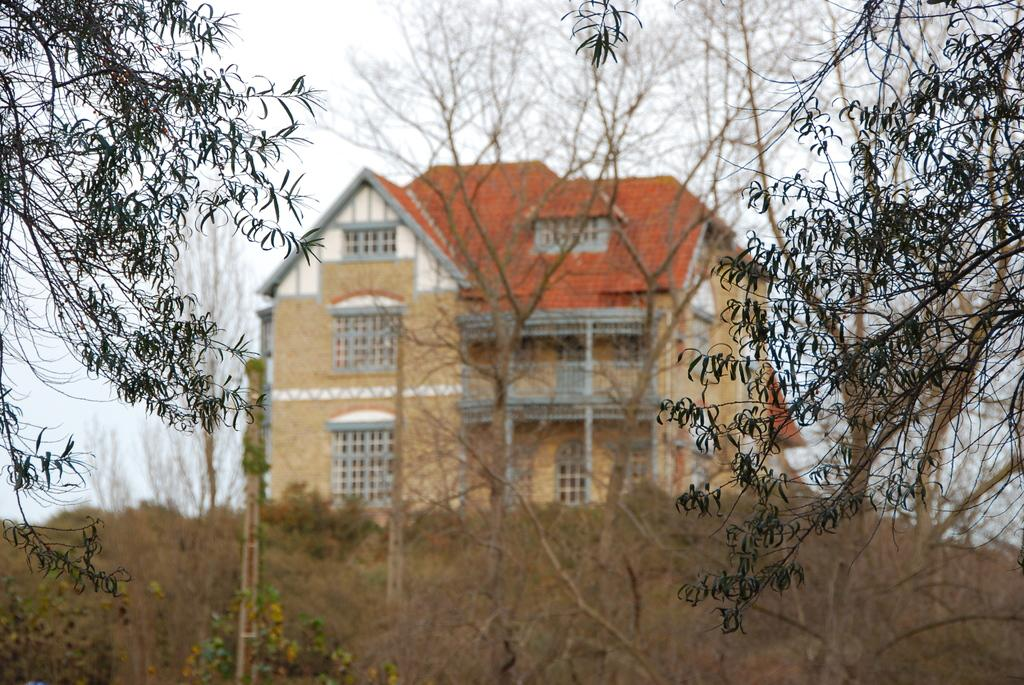What type of natural elements are present on the ground in the image? There are trees and plants on the ground in the image. What type of man-made structure can be seen in the background of the image? There is a building in the background of the image. What part of the natural environment is visible in the image? The sky is visible in the background of the image. What type of error can be seen in the image? There is no error present in the image. Is there a gate visible in the image? There is no gate present in the image. 